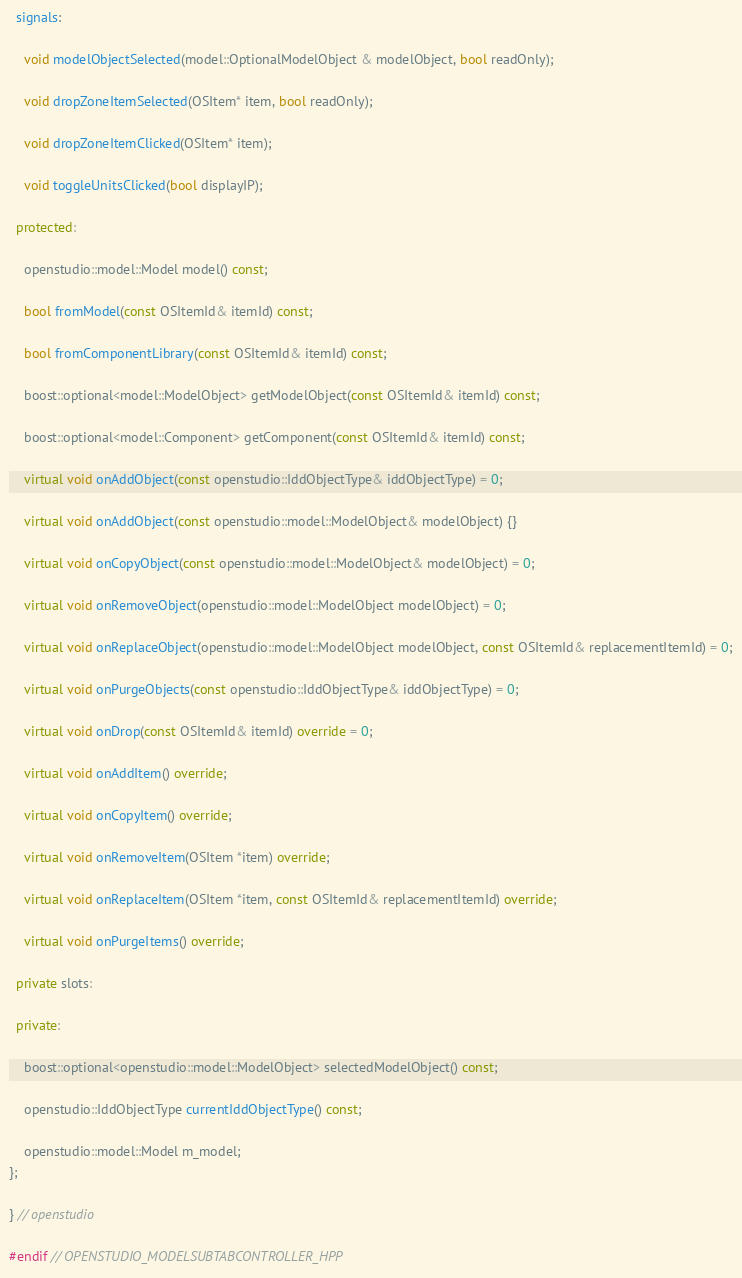Convert code to text. <code><loc_0><loc_0><loc_500><loc_500><_C++_>  signals:

    void modelObjectSelected(model::OptionalModelObject & modelObject, bool readOnly);

    void dropZoneItemSelected(OSItem* item, bool readOnly);

    void dropZoneItemClicked(OSItem* item);

    void toggleUnitsClicked(bool displayIP);

  protected:

    openstudio::model::Model model() const;

    bool fromModel(const OSItemId& itemId) const;

    bool fromComponentLibrary(const OSItemId& itemId) const;

    boost::optional<model::ModelObject> getModelObject(const OSItemId& itemId) const;

    boost::optional<model::Component> getComponent(const OSItemId& itemId) const;

    virtual void onAddObject(const openstudio::IddObjectType& iddObjectType) = 0;

    virtual void onAddObject(const openstudio::model::ModelObject& modelObject) {}

    virtual void onCopyObject(const openstudio::model::ModelObject& modelObject) = 0;

    virtual void onRemoveObject(openstudio::model::ModelObject modelObject) = 0;

    virtual void onReplaceObject(openstudio::model::ModelObject modelObject, const OSItemId& replacementItemId) = 0;

    virtual void onPurgeObjects(const openstudio::IddObjectType& iddObjectType) = 0;

    virtual void onDrop(const OSItemId& itemId) override = 0;

    virtual void onAddItem() override;

    virtual void onCopyItem() override;

    virtual void onRemoveItem(OSItem *item) override;

    virtual void onReplaceItem(OSItem *item, const OSItemId& replacementItemId) override;

    virtual void onPurgeItems() override;

  private slots:

  private:

    boost::optional<openstudio::model::ModelObject> selectedModelObject() const;

    openstudio::IddObjectType currentIddObjectType() const;

    openstudio::model::Model m_model;
};

} // openstudio

#endif // OPENSTUDIO_MODELSUBTABCONTROLLER_HPP
</code> 